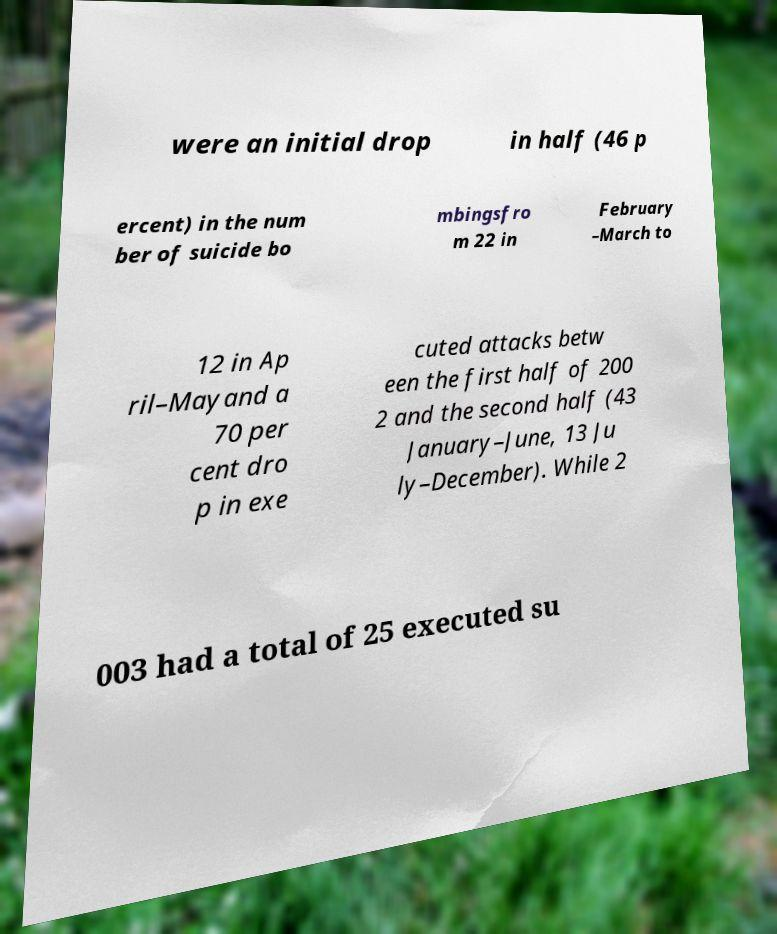Can you accurately transcribe the text from the provided image for me? were an initial drop in half (46 p ercent) in the num ber of suicide bo mbingsfro m 22 in February –March to 12 in Ap ril–Mayand a 70 per cent dro p in exe cuted attacks betw een the first half of 200 2 and the second half (43 January–June, 13 Ju ly–December). While 2 003 had a total of 25 executed su 